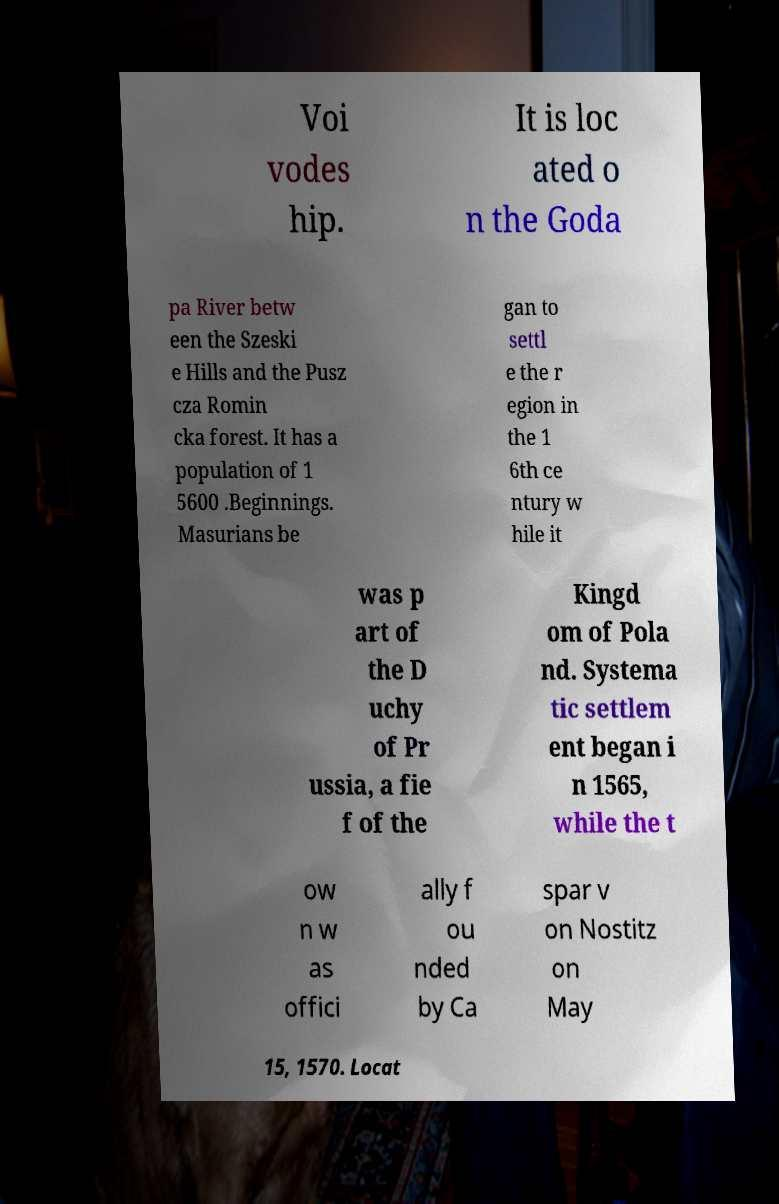For documentation purposes, I need the text within this image transcribed. Could you provide that? Voi vodes hip. It is loc ated o n the Goda pa River betw een the Szeski e Hills and the Pusz cza Romin cka forest. It has a population of 1 5600 .Beginnings. Masurians be gan to settl e the r egion in the 1 6th ce ntury w hile it was p art of the D uchy of Pr ussia, a fie f of the Kingd om of Pola nd. Systema tic settlem ent began i n 1565, while the t ow n w as offici ally f ou nded by Ca spar v on Nostitz on May 15, 1570. Locat 